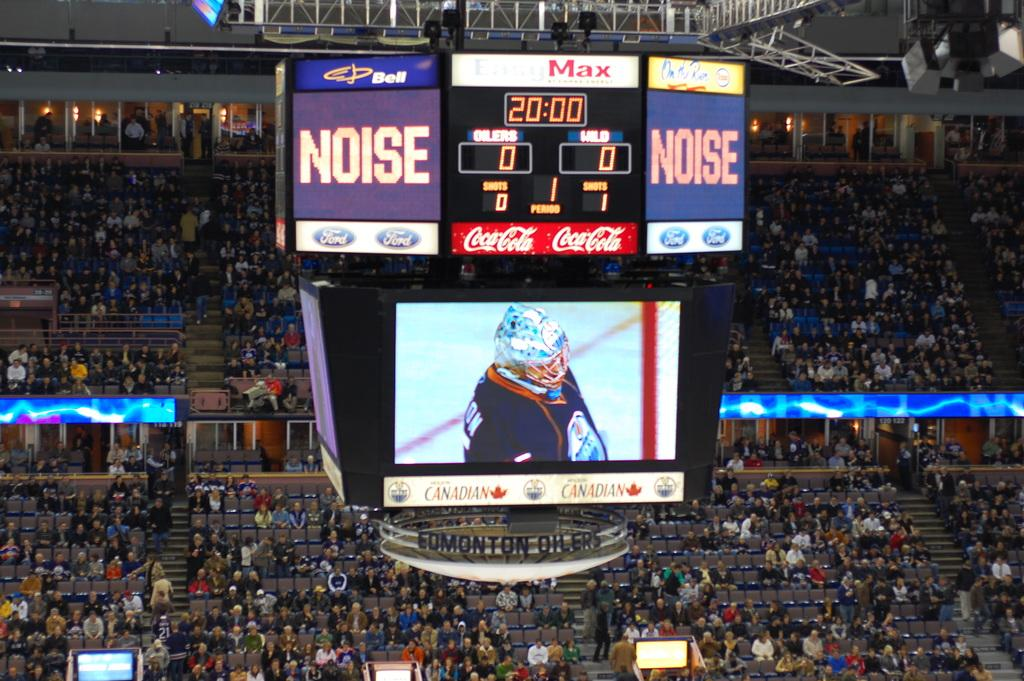<image>
Share a concise interpretation of the image provided. People sitting in packed bleachers at a Noise hockey game 